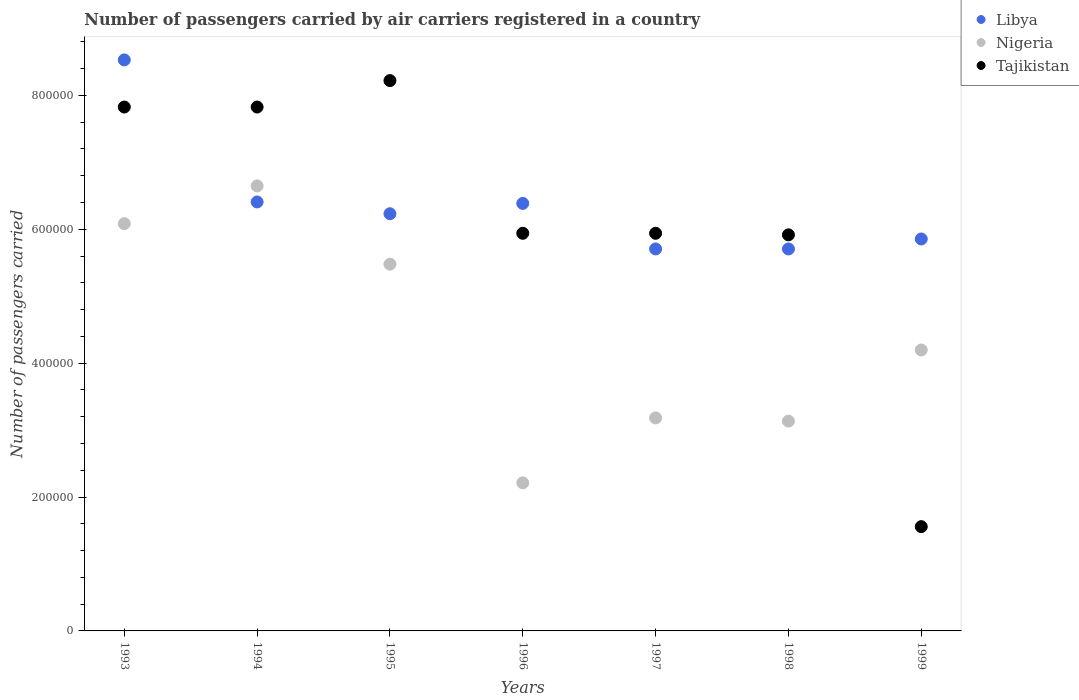How many different coloured dotlines are there?
Keep it short and to the point. 3. Is the number of dotlines equal to the number of legend labels?
Provide a succinct answer. Yes. What is the number of passengers carried by air carriers in Libya in 1993?
Offer a very short reply. 8.53e+05. Across all years, what is the maximum number of passengers carried by air carriers in Nigeria?
Give a very brief answer. 6.65e+05. Across all years, what is the minimum number of passengers carried by air carriers in Nigeria?
Provide a succinct answer. 2.21e+05. In which year was the number of passengers carried by air carriers in Tajikistan minimum?
Your answer should be very brief. 1999. What is the total number of passengers carried by air carriers in Tajikistan in the graph?
Your answer should be very brief. 4.32e+06. What is the difference between the number of passengers carried by air carriers in Nigeria in 1994 and that in 1999?
Offer a terse response. 2.45e+05. What is the difference between the number of passengers carried by air carriers in Tajikistan in 1993 and the number of passengers carried by air carriers in Nigeria in 1999?
Offer a very short reply. 3.63e+05. What is the average number of passengers carried by air carriers in Nigeria per year?
Give a very brief answer. 4.42e+05. In the year 1998, what is the difference between the number of passengers carried by air carriers in Libya and number of passengers carried by air carriers in Nigeria?
Provide a succinct answer. 2.57e+05. What is the ratio of the number of passengers carried by air carriers in Tajikistan in 1994 to that in 1997?
Provide a succinct answer. 1.32. Is the number of passengers carried by air carriers in Libya in 1994 less than that in 1996?
Ensure brevity in your answer.  No. Is the difference between the number of passengers carried by air carriers in Libya in 1997 and 1998 greater than the difference between the number of passengers carried by air carriers in Nigeria in 1997 and 1998?
Your answer should be very brief. No. What is the difference between the highest and the second highest number of passengers carried by air carriers in Nigeria?
Keep it short and to the point. 5.64e+04. What is the difference between the highest and the lowest number of passengers carried by air carriers in Nigeria?
Your answer should be very brief. 4.44e+05. Is the sum of the number of passengers carried by air carriers in Nigeria in 1997 and 1999 greater than the maximum number of passengers carried by air carriers in Tajikistan across all years?
Offer a very short reply. No. Is it the case that in every year, the sum of the number of passengers carried by air carriers in Libya and number of passengers carried by air carriers in Tajikistan  is greater than the number of passengers carried by air carriers in Nigeria?
Your answer should be very brief. Yes. Does the number of passengers carried by air carriers in Nigeria monotonically increase over the years?
Ensure brevity in your answer.  No. Is the number of passengers carried by air carriers in Libya strictly less than the number of passengers carried by air carriers in Nigeria over the years?
Give a very brief answer. No. How many dotlines are there?
Provide a short and direct response. 3. Does the graph contain any zero values?
Offer a very short reply. No. Where does the legend appear in the graph?
Ensure brevity in your answer.  Top right. How many legend labels are there?
Offer a terse response. 3. What is the title of the graph?
Provide a short and direct response. Number of passengers carried by air carriers registered in a country. What is the label or title of the Y-axis?
Offer a very short reply. Number of passengers carried. What is the Number of passengers carried in Libya in 1993?
Keep it short and to the point. 8.53e+05. What is the Number of passengers carried of Nigeria in 1993?
Keep it short and to the point. 6.08e+05. What is the Number of passengers carried in Tajikistan in 1993?
Your answer should be very brief. 7.83e+05. What is the Number of passengers carried in Libya in 1994?
Make the answer very short. 6.41e+05. What is the Number of passengers carried in Nigeria in 1994?
Offer a very short reply. 6.65e+05. What is the Number of passengers carried in Tajikistan in 1994?
Provide a short and direct response. 7.83e+05. What is the Number of passengers carried in Libya in 1995?
Offer a terse response. 6.23e+05. What is the Number of passengers carried of Nigeria in 1995?
Your answer should be very brief. 5.48e+05. What is the Number of passengers carried in Tajikistan in 1995?
Your answer should be compact. 8.22e+05. What is the Number of passengers carried of Libya in 1996?
Make the answer very short. 6.39e+05. What is the Number of passengers carried of Nigeria in 1996?
Keep it short and to the point. 2.21e+05. What is the Number of passengers carried of Tajikistan in 1996?
Your answer should be very brief. 5.94e+05. What is the Number of passengers carried of Libya in 1997?
Your answer should be compact. 5.71e+05. What is the Number of passengers carried of Nigeria in 1997?
Your response must be concise. 3.18e+05. What is the Number of passengers carried in Tajikistan in 1997?
Provide a succinct answer. 5.94e+05. What is the Number of passengers carried in Libya in 1998?
Make the answer very short. 5.71e+05. What is the Number of passengers carried in Nigeria in 1998?
Give a very brief answer. 3.13e+05. What is the Number of passengers carried of Tajikistan in 1998?
Offer a very short reply. 5.92e+05. What is the Number of passengers carried of Libya in 1999?
Offer a very short reply. 5.86e+05. What is the Number of passengers carried of Nigeria in 1999?
Your response must be concise. 4.20e+05. What is the Number of passengers carried in Tajikistan in 1999?
Provide a succinct answer. 1.56e+05. Across all years, what is the maximum Number of passengers carried of Libya?
Provide a short and direct response. 8.53e+05. Across all years, what is the maximum Number of passengers carried of Nigeria?
Offer a very short reply. 6.65e+05. Across all years, what is the maximum Number of passengers carried in Tajikistan?
Your answer should be compact. 8.22e+05. Across all years, what is the minimum Number of passengers carried in Libya?
Your answer should be very brief. 5.71e+05. Across all years, what is the minimum Number of passengers carried in Nigeria?
Your answer should be very brief. 2.21e+05. Across all years, what is the minimum Number of passengers carried in Tajikistan?
Ensure brevity in your answer.  1.56e+05. What is the total Number of passengers carried of Libya in the graph?
Your answer should be compact. 4.48e+06. What is the total Number of passengers carried of Nigeria in the graph?
Your answer should be compact. 3.09e+06. What is the total Number of passengers carried in Tajikistan in the graph?
Make the answer very short. 4.32e+06. What is the difference between the Number of passengers carried of Libya in 1993 and that in 1994?
Keep it short and to the point. 2.12e+05. What is the difference between the Number of passengers carried of Nigeria in 1993 and that in 1994?
Give a very brief answer. -5.64e+04. What is the difference between the Number of passengers carried of Libya in 1993 and that in 1995?
Make the answer very short. 2.30e+05. What is the difference between the Number of passengers carried of Nigeria in 1993 and that in 1995?
Provide a succinct answer. 6.05e+04. What is the difference between the Number of passengers carried in Tajikistan in 1993 and that in 1995?
Your answer should be very brief. -3.95e+04. What is the difference between the Number of passengers carried in Libya in 1993 and that in 1996?
Provide a succinct answer. 2.14e+05. What is the difference between the Number of passengers carried in Nigeria in 1993 and that in 1996?
Offer a very short reply. 3.87e+05. What is the difference between the Number of passengers carried of Tajikistan in 1993 and that in 1996?
Provide a short and direct response. 1.89e+05. What is the difference between the Number of passengers carried of Libya in 1993 and that in 1997?
Offer a very short reply. 2.82e+05. What is the difference between the Number of passengers carried of Nigeria in 1993 and that in 1997?
Make the answer very short. 2.90e+05. What is the difference between the Number of passengers carried in Tajikistan in 1993 and that in 1997?
Make the answer very short. 1.89e+05. What is the difference between the Number of passengers carried of Libya in 1993 and that in 1998?
Ensure brevity in your answer.  2.82e+05. What is the difference between the Number of passengers carried of Nigeria in 1993 and that in 1998?
Provide a succinct answer. 2.95e+05. What is the difference between the Number of passengers carried of Tajikistan in 1993 and that in 1998?
Make the answer very short. 1.91e+05. What is the difference between the Number of passengers carried in Libya in 1993 and that in 1999?
Make the answer very short. 2.68e+05. What is the difference between the Number of passengers carried in Nigeria in 1993 and that in 1999?
Give a very brief answer. 1.89e+05. What is the difference between the Number of passengers carried of Tajikistan in 1993 and that in 1999?
Give a very brief answer. 6.27e+05. What is the difference between the Number of passengers carried of Libya in 1994 and that in 1995?
Provide a short and direct response. 1.76e+04. What is the difference between the Number of passengers carried in Nigeria in 1994 and that in 1995?
Your response must be concise. 1.17e+05. What is the difference between the Number of passengers carried of Tajikistan in 1994 and that in 1995?
Provide a short and direct response. -3.95e+04. What is the difference between the Number of passengers carried in Libya in 1994 and that in 1996?
Offer a terse response. 2200. What is the difference between the Number of passengers carried of Nigeria in 1994 and that in 1996?
Offer a terse response. 4.44e+05. What is the difference between the Number of passengers carried of Tajikistan in 1994 and that in 1996?
Offer a very short reply. 1.89e+05. What is the difference between the Number of passengers carried in Libya in 1994 and that in 1997?
Keep it short and to the point. 7.02e+04. What is the difference between the Number of passengers carried in Nigeria in 1994 and that in 1997?
Offer a very short reply. 3.47e+05. What is the difference between the Number of passengers carried in Tajikistan in 1994 and that in 1997?
Provide a succinct answer. 1.89e+05. What is the difference between the Number of passengers carried of Libya in 1994 and that in 1998?
Provide a short and direct response. 7.02e+04. What is the difference between the Number of passengers carried in Nigeria in 1994 and that in 1998?
Offer a terse response. 3.51e+05. What is the difference between the Number of passengers carried of Tajikistan in 1994 and that in 1998?
Make the answer very short. 1.91e+05. What is the difference between the Number of passengers carried of Libya in 1994 and that in 1999?
Offer a very short reply. 5.53e+04. What is the difference between the Number of passengers carried of Nigeria in 1994 and that in 1999?
Your answer should be very brief. 2.45e+05. What is the difference between the Number of passengers carried of Tajikistan in 1994 and that in 1999?
Offer a very short reply. 6.27e+05. What is the difference between the Number of passengers carried in Libya in 1995 and that in 1996?
Keep it short and to the point. -1.54e+04. What is the difference between the Number of passengers carried in Nigeria in 1995 and that in 1996?
Your answer should be compact. 3.27e+05. What is the difference between the Number of passengers carried in Tajikistan in 1995 and that in 1996?
Your answer should be compact. 2.28e+05. What is the difference between the Number of passengers carried of Libya in 1995 and that in 1997?
Offer a very short reply. 5.26e+04. What is the difference between the Number of passengers carried of Nigeria in 1995 and that in 1997?
Your answer should be very brief. 2.30e+05. What is the difference between the Number of passengers carried of Tajikistan in 1995 and that in 1997?
Your answer should be compact. 2.28e+05. What is the difference between the Number of passengers carried in Libya in 1995 and that in 1998?
Offer a very short reply. 5.26e+04. What is the difference between the Number of passengers carried in Nigeria in 1995 and that in 1998?
Make the answer very short. 2.34e+05. What is the difference between the Number of passengers carried of Tajikistan in 1995 and that in 1998?
Offer a very short reply. 2.30e+05. What is the difference between the Number of passengers carried in Libya in 1995 and that in 1999?
Your response must be concise. 3.77e+04. What is the difference between the Number of passengers carried of Nigeria in 1995 and that in 1999?
Offer a terse response. 1.28e+05. What is the difference between the Number of passengers carried in Tajikistan in 1995 and that in 1999?
Provide a succinct answer. 6.66e+05. What is the difference between the Number of passengers carried of Libya in 1996 and that in 1997?
Your response must be concise. 6.80e+04. What is the difference between the Number of passengers carried in Nigeria in 1996 and that in 1997?
Make the answer very short. -9.70e+04. What is the difference between the Number of passengers carried in Tajikistan in 1996 and that in 1997?
Offer a very short reply. 0. What is the difference between the Number of passengers carried in Libya in 1996 and that in 1998?
Your answer should be compact. 6.80e+04. What is the difference between the Number of passengers carried of Nigeria in 1996 and that in 1998?
Your answer should be very brief. -9.22e+04. What is the difference between the Number of passengers carried of Tajikistan in 1996 and that in 1998?
Your response must be concise. 2300. What is the difference between the Number of passengers carried in Libya in 1996 and that in 1999?
Provide a succinct answer. 5.31e+04. What is the difference between the Number of passengers carried of Nigeria in 1996 and that in 1999?
Offer a terse response. -1.98e+05. What is the difference between the Number of passengers carried of Tajikistan in 1996 and that in 1999?
Keep it short and to the point. 4.38e+05. What is the difference between the Number of passengers carried in Nigeria in 1997 and that in 1998?
Give a very brief answer. 4800. What is the difference between the Number of passengers carried of Tajikistan in 1997 and that in 1998?
Offer a terse response. 2300. What is the difference between the Number of passengers carried of Libya in 1997 and that in 1999?
Make the answer very short. -1.49e+04. What is the difference between the Number of passengers carried of Nigeria in 1997 and that in 1999?
Offer a terse response. -1.02e+05. What is the difference between the Number of passengers carried of Tajikistan in 1997 and that in 1999?
Keep it short and to the point. 4.38e+05. What is the difference between the Number of passengers carried of Libya in 1998 and that in 1999?
Ensure brevity in your answer.  -1.49e+04. What is the difference between the Number of passengers carried in Nigeria in 1998 and that in 1999?
Give a very brief answer. -1.06e+05. What is the difference between the Number of passengers carried of Tajikistan in 1998 and that in 1999?
Keep it short and to the point. 4.36e+05. What is the difference between the Number of passengers carried of Libya in 1993 and the Number of passengers carried of Nigeria in 1994?
Your response must be concise. 1.88e+05. What is the difference between the Number of passengers carried of Libya in 1993 and the Number of passengers carried of Tajikistan in 1994?
Your answer should be very brief. 7.04e+04. What is the difference between the Number of passengers carried in Nigeria in 1993 and the Number of passengers carried in Tajikistan in 1994?
Your answer should be compact. -1.74e+05. What is the difference between the Number of passengers carried in Libya in 1993 and the Number of passengers carried in Nigeria in 1995?
Offer a very short reply. 3.05e+05. What is the difference between the Number of passengers carried of Libya in 1993 and the Number of passengers carried of Tajikistan in 1995?
Provide a short and direct response. 3.09e+04. What is the difference between the Number of passengers carried of Nigeria in 1993 and the Number of passengers carried of Tajikistan in 1995?
Provide a succinct answer. -2.14e+05. What is the difference between the Number of passengers carried of Libya in 1993 and the Number of passengers carried of Nigeria in 1996?
Your answer should be very brief. 6.32e+05. What is the difference between the Number of passengers carried of Libya in 1993 and the Number of passengers carried of Tajikistan in 1996?
Your response must be concise. 2.59e+05. What is the difference between the Number of passengers carried in Nigeria in 1993 and the Number of passengers carried in Tajikistan in 1996?
Ensure brevity in your answer.  1.44e+04. What is the difference between the Number of passengers carried of Libya in 1993 and the Number of passengers carried of Nigeria in 1997?
Offer a terse response. 5.35e+05. What is the difference between the Number of passengers carried of Libya in 1993 and the Number of passengers carried of Tajikistan in 1997?
Give a very brief answer. 2.59e+05. What is the difference between the Number of passengers carried of Nigeria in 1993 and the Number of passengers carried of Tajikistan in 1997?
Offer a terse response. 1.44e+04. What is the difference between the Number of passengers carried of Libya in 1993 and the Number of passengers carried of Nigeria in 1998?
Give a very brief answer. 5.40e+05. What is the difference between the Number of passengers carried in Libya in 1993 and the Number of passengers carried in Tajikistan in 1998?
Offer a terse response. 2.61e+05. What is the difference between the Number of passengers carried of Nigeria in 1993 and the Number of passengers carried of Tajikistan in 1998?
Keep it short and to the point. 1.67e+04. What is the difference between the Number of passengers carried of Libya in 1993 and the Number of passengers carried of Nigeria in 1999?
Your response must be concise. 4.33e+05. What is the difference between the Number of passengers carried in Libya in 1993 and the Number of passengers carried in Tajikistan in 1999?
Offer a terse response. 6.97e+05. What is the difference between the Number of passengers carried of Nigeria in 1993 and the Number of passengers carried of Tajikistan in 1999?
Make the answer very short. 4.53e+05. What is the difference between the Number of passengers carried of Libya in 1994 and the Number of passengers carried of Nigeria in 1995?
Give a very brief answer. 9.29e+04. What is the difference between the Number of passengers carried in Libya in 1994 and the Number of passengers carried in Tajikistan in 1995?
Give a very brief answer. -1.81e+05. What is the difference between the Number of passengers carried of Nigeria in 1994 and the Number of passengers carried of Tajikistan in 1995?
Provide a succinct answer. -1.57e+05. What is the difference between the Number of passengers carried of Libya in 1994 and the Number of passengers carried of Nigeria in 1996?
Your response must be concise. 4.20e+05. What is the difference between the Number of passengers carried of Libya in 1994 and the Number of passengers carried of Tajikistan in 1996?
Give a very brief answer. 4.68e+04. What is the difference between the Number of passengers carried in Nigeria in 1994 and the Number of passengers carried in Tajikistan in 1996?
Your response must be concise. 7.08e+04. What is the difference between the Number of passengers carried in Libya in 1994 and the Number of passengers carried in Nigeria in 1997?
Provide a succinct answer. 3.23e+05. What is the difference between the Number of passengers carried of Libya in 1994 and the Number of passengers carried of Tajikistan in 1997?
Give a very brief answer. 4.68e+04. What is the difference between the Number of passengers carried in Nigeria in 1994 and the Number of passengers carried in Tajikistan in 1997?
Offer a very short reply. 7.08e+04. What is the difference between the Number of passengers carried of Libya in 1994 and the Number of passengers carried of Nigeria in 1998?
Your response must be concise. 3.27e+05. What is the difference between the Number of passengers carried of Libya in 1994 and the Number of passengers carried of Tajikistan in 1998?
Give a very brief answer. 4.91e+04. What is the difference between the Number of passengers carried of Nigeria in 1994 and the Number of passengers carried of Tajikistan in 1998?
Your response must be concise. 7.31e+04. What is the difference between the Number of passengers carried in Libya in 1994 and the Number of passengers carried in Nigeria in 1999?
Provide a short and direct response. 2.21e+05. What is the difference between the Number of passengers carried in Libya in 1994 and the Number of passengers carried in Tajikistan in 1999?
Keep it short and to the point. 4.85e+05. What is the difference between the Number of passengers carried in Nigeria in 1994 and the Number of passengers carried in Tajikistan in 1999?
Your answer should be very brief. 5.09e+05. What is the difference between the Number of passengers carried in Libya in 1995 and the Number of passengers carried in Nigeria in 1996?
Offer a very short reply. 4.02e+05. What is the difference between the Number of passengers carried in Libya in 1995 and the Number of passengers carried in Tajikistan in 1996?
Make the answer very short. 2.92e+04. What is the difference between the Number of passengers carried in Nigeria in 1995 and the Number of passengers carried in Tajikistan in 1996?
Make the answer very short. -4.61e+04. What is the difference between the Number of passengers carried in Libya in 1995 and the Number of passengers carried in Nigeria in 1997?
Offer a terse response. 3.05e+05. What is the difference between the Number of passengers carried of Libya in 1995 and the Number of passengers carried of Tajikistan in 1997?
Offer a very short reply. 2.92e+04. What is the difference between the Number of passengers carried in Nigeria in 1995 and the Number of passengers carried in Tajikistan in 1997?
Ensure brevity in your answer.  -4.61e+04. What is the difference between the Number of passengers carried in Libya in 1995 and the Number of passengers carried in Nigeria in 1998?
Your answer should be compact. 3.10e+05. What is the difference between the Number of passengers carried in Libya in 1995 and the Number of passengers carried in Tajikistan in 1998?
Make the answer very short. 3.15e+04. What is the difference between the Number of passengers carried in Nigeria in 1995 and the Number of passengers carried in Tajikistan in 1998?
Ensure brevity in your answer.  -4.38e+04. What is the difference between the Number of passengers carried in Libya in 1995 and the Number of passengers carried in Nigeria in 1999?
Provide a succinct answer. 2.04e+05. What is the difference between the Number of passengers carried in Libya in 1995 and the Number of passengers carried in Tajikistan in 1999?
Your answer should be compact. 4.67e+05. What is the difference between the Number of passengers carried of Nigeria in 1995 and the Number of passengers carried of Tajikistan in 1999?
Your response must be concise. 3.92e+05. What is the difference between the Number of passengers carried of Libya in 1996 and the Number of passengers carried of Nigeria in 1997?
Make the answer very short. 3.20e+05. What is the difference between the Number of passengers carried in Libya in 1996 and the Number of passengers carried in Tajikistan in 1997?
Offer a terse response. 4.46e+04. What is the difference between the Number of passengers carried of Nigeria in 1996 and the Number of passengers carried of Tajikistan in 1997?
Your response must be concise. -3.73e+05. What is the difference between the Number of passengers carried of Libya in 1996 and the Number of passengers carried of Nigeria in 1998?
Your answer should be compact. 3.25e+05. What is the difference between the Number of passengers carried of Libya in 1996 and the Number of passengers carried of Tajikistan in 1998?
Your answer should be compact. 4.69e+04. What is the difference between the Number of passengers carried of Nigeria in 1996 and the Number of passengers carried of Tajikistan in 1998?
Your answer should be compact. -3.70e+05. What is the difference between the Number of passengers carried of Libya in 1996 and the Number of passengers carried of Nigeria in 1999?
Offer a very short reply. 2.19e+05. What is the difference between the Number of passengers carried of Libya in 1996 and the Number of passengers carried of Tajikistan in 1999?
Give a very brief answer. 4.83e+05. What is the difference between the Number of passengers carried in Nigeria in 1996 and the Number of passengers carried in Tajikistan in 1999?
Provide a succinct answer. 6.54e+04. What is the difference between the Number of passengers carried in Libya in 1997 and the Number of passengers carried in Nigeria in 1998?
Offer a terse response. 2.57e+05. What is the difference between the Number of passengers carried in Libya in 1997 and the Number of passengers carried in Tajikistan in 1998?
Offer a very short reply. -2.11e+04. What is the difference between the Number of passengers carried in Nigeria in 1997 and the Number of passengers carried in Tajikistan in 1998?
Your response must be concise. -2.74e+05. What is the difference between the Number of passengers carried in Libya in 1997 and the Number of passengers carried in Nigeria in 1999?
Make the answer very short. 1.51e+05. What is the difference between the Number of passengers carried in Libya in 1997 and the Number of passengers carried in Tajikistan in 1999?
Offer a terse response. 4.15e+05. What is the difference between the Number of passengers carried in Nigeria in 1997 and the Number of passengers carried in Tajikistan in 1999?
Provide a succinct answer. 1.62e+05. What is the difference between the Number of passengers carried of Libya in 1998 and the Number of passengers carried of Nigeria in 1999?
Make the answer very short. 1.51e+05. What is the difference between the Number of passengers carried of Libya in 1998 and the Number of passengers carried of Tajikistan in 1999?
Provide a succinct answer. 4.15e+05. What is the difference between the Number of passengers carried in Nigeria in 1998 and the Number of passengers carried in Tajikistan in 1999?
Your response must be concise. 1.58e+05. What is the average Number of passengers carried in Libya per year?
Ensure brevity in your answer.  6.40e+05. What is the average Number of passengers carried of Nigeria per year?
Offer a very short reply. 4.42e+05. What is the average Number of passengers carried of Tajikistan per year?
Provide a short and direct response. 6.18e+05. In the year 1993, what is the difference between the Number of passengers carried of Libya and Number of passengers carried of Nigeria?
Offer a terse response. 2.45e+05. In the year 1993, what is the difference between the Number of passengers carried in Libya and Number of passengers carried in Tajikistan?
Provide a short and direct response. 7.04e+04. In the year 1993, what is the difference between the Number of passengers carried of Nigeria and Number of passengers carried of Tajikistan?
Give a very brief answer. -1.74e+05. In the year 1994, what is the difference between the Number of passengers carried of Libya and Number of passengers carried of Nigeria?
Ensure brevity in your answer.  -2.40e+04. In the year 1994, what is the difference between the Number of passengers carried of Libya and Number of passengers carried of Tajikistan?
Your answer should be compact. -1.42e+05. In the year 1994, what is the difference between the Number of passengers carried in Nigeria and Number of passengers carried in Tajikistan?
Your answer should be compact. -1.18e+05. In the year 1995, what is the difference between the Number of passengers carried of Libya and Number of passengers carried of Nigeria?
Your answer should be very brief. 7.53e+04. In the year 1995, what is the difference between the Number of passengers carried in Libya and Number of passengers carried in Tajikistan?
Keep it short and to the point. -1.99e+05. In the year 1995, what is the difference between the Number of passengers carried in Nigeria and Number of passengers carried in Tajikistan?
Provide a short and direct response. -2.74e+05. In the year 1996, what is the difference between the Number of passengers carried in Libya and Number of passengers carried in Nigeria?
Give a very brief answer. 4.17e+05. In the year 1996, what is the difference between the Number of passengers carried of Libya and Number of passengers carried of Tajikistan?
Your answer should be compact. 4.46e+04. In the year 1996, what is the difference between the Number of passengers carried of Nigeria and Number of passengers carried of Tajikistan?
Your answer should be very brief. -3.73e+05. In the year 1997, what is the difference between the Number of passengers carried of Libya and Number of passengers carried of Nigeria?
Your answer should be very brief. 2.52e+05. In the year 1997, what is the difference between the Number of passengers carried of Libya and Number of passengers carried of Tajikistan?
Provide a succinct answer. -2.34e+04. In the year 1997, what is the difference between the Number of passengers carried in Nigeria and Number of passengers carried in Tajikistan?
Your answer should be very brief. -2.76e+05. In the year 1998, what is the difference between the Number of passengers carried in Libya and Number of passengers carried in Nigeria?
Your answer should be very brief. 2.57e+05. In the year 1998, what is the difference between the Number of passengers carried of Libya and Number of passengers carried of Tajikistan?
Offer a terse response. -2.11e+04. In the year 1998, what is the difference between the Number of passengers carried in Nigeria and Number of passengers carried in Tajikistan?
Provide a succinct answer. -2.78e+05. In the year 1999, what is the difference between the Number of passengers carried of Libya and Number of passengers carried of Nigeria?
Offer a very short reply. 1.66e+05. In the year 1999, what is the difference between the Number of passengers carried of Libya and Number of passengers carried of Tajikistan?
Provide a short and direct response. 4.30e+05. In the year 1999, what is the difference between the Number of passengers carried in Nigeria and Number of passengers carried in Tajikistan?
Offer a terse response. 2.64e+05. What is the ratio of the Number of passengers carried in Libya in 1993 to that in 1994?
Make the answer very short. 1.33. What is the ratio of the Number of passengers carried in Nigeria in 1993 to that in 1994?
Provide a short and direct response. 0.92. What is the ratio of the Number of passengers carried in Tajikistan in 1993 to that in 1994?
Give a very brief answer. 1. What is the ratio of the Number of passengers carried in Libya in 1993 to that in 1995?
Provide a succinct answer. 1.37. What is the ratio of the Number of passengers carried in Nigeria in 1993 to that in 1995?
Make the answer very short. 1.11. What is the ratio of the Number of passengers carried in Libya in 1993 to that in 1996?
Your answer should be very brief. 1.34. What is the ratio of the Number of passengers carried of Nigeria in 1993 to that in 1996?
Make the answer very short. 2.75. What is the ratio of the Number of passengers carried of Tajikistan in 1993 to that in 1996?
Offer a terse response. 1.32. What is the ratio of the Number of passengers carried in Libya in 1993 to that in 1997?
Keep it short and to the point. 1.49. What is the ratio of the Number of passengers carried of Nigeria in 1993 to that in 1997?
Keep it short and to the point. 1.91. What is the ratio of the Number of passengers carried in Tajikistan in 1993 to that in 1997?
Offer a terse response. 1.32. What is the ratio of the Number of passengers carried of Libya in 1993 to that in 1998?
Make the answer very short. 1.49. What is the ratio of the Number of passengers carried in Nigeria in 1993 to that in 1998?
Give a very brief answer. 1.94. What is the ratio of the Number of passengers carried in Tajikistan in 1993 to that in 1998?
Keep it short and to the point. 1.32. What is the ratio of the Number of passengers carried of Libya in 1993 to that in 1999?
Your answer should be very brief. 1.46. What is the ratio of the Number of passengers carried of Nigeria in 1993 to that in 1999?
Your answer should be very brief. 1.45. What is the ratio of the Number of passengers carried of Tajikistan in 1993 to that in 1999?
Provide a short and direct response. 5.02. What is the ratio of the Number of passengers carried in Libya in 1994 to that in 1995?
Provide a succinct answer. 1.03. What is the ratio of the Number of passengers carried of Nigeria in 1994 to that in 1995?
Offer a terse response. 1.21. What is the ratio of the Number of passengers carried of Tajikistan in 1994 to that in 1995?
Ensure brevity in your answer.  0.95. What is the ratio of the Number of passengers carried in Nigeria in 1994 to that in 1996?
Make the answer very short. 3.01. What is the ratio of the Number of passengers carried in Tajikistan in 1994 to that in 1996?
Ensure brevity in your answer.  1.32. What is the ratio of the Number of passengers carried in Libya in 1994 to that in 1997?
Ensure brevity in your answer.  1.12. What is the ratio of the Number of passengers carried of Nigeria in 1994 to that in 1997?
Ensure brevity in your answer.  2.09. What is the ratio of the Number of passengers carried in Tajikistan in 1994 to that in 1997?
Provide a succinct answer. 1.32. What is the ratio of the Number of passengers carried of Libya in 1994 to that in 1998?
Your answer should be compact. 1.12. What is the ratio of the Number of passengers carried in Nigeria in 1994 to that in 1998?
Your response must be concise. 2.12. What is the ratio of the Number of passengers carried of Tajikistan in 1994 to that in 1998?
Offer a terse response. 1.32. What is the ratio of the Number of passengers carried in Libya in 1994 to that in 1999?
Your answer should be very brief. 1.09. What is the ratio of the Number of passengers carried of Nigeria in 1994 to that in 1999?
Give a very brief answer. 1.58. What is the ratio of the Number of passengers carried in Tajikistan in 1994 to that in 1999?
Make the answer very short. 5.02. What is the ratio of the Number of passengers carried in Libya in 1995 to that in 1996?
Your answer should be compact. 0.98. What is the ratio of the Number of passengers carried of Nigeria in 1995 to that in 1996?
Offer a terse response. 2.48. What is the ratio of the Number of passengers carried in Tajikistan in 1995 to that in 1996?
Your answer should be very brief. 1.38. What is the ratio of the Number of passengers carried in Libya in 1995 to that in 1997?
Make the answer very short. 1.09. What is the ratio of the Number of passengers carried of Nigeria in 1995 to that in 1997?
Give a very brief answer. 1.72. What is the ratio of the Number of passengers carried in Tajikistan in 1995 to that in 1997?
Provide a short and direct response. 1.38. What is the ratio of the Number of passengers carried of Libya in 1995 to that in 1998?
Your answer should be very brief. 1.09. What is the ratio of the Number of passengers carried in Nigeria in 1995 to that in 1998?
Offer a terse response. 1.75. What is the ratio of the Number of passengers carried in Tajikistan in 1995 to that in 1998?
Offer a very short reply. 1.39. What is the ratio of the Number of passengers carried in Libya in 1995 to that in 1999?
Make the answer very short. 1.06. What is the ratio of the Number of passengers carried of Nigeria in 1995 to that in 1999?
Provide a succinct answer. 1.31. What is the ratio of the Number of passengers carried of Tajikistan in 1995 to that in 1999?
Your answer should be compact. 5.28. What is the ratio of the Number of passengers carried of Libya in 1996 to that in 1997?
Your response must be concise. 1.12. What is the ratio of the Number of passengers carried in Nigeria in 1996 to that in 1997?
Keep it short and to the point. 0.7. What is the ratio of the Number of passengers carried of Libya in 1996 to that in 1998?
Provide a short and direct response. 1.12. What is the ratio of the Number of passengers carried of Nigeria in 1996 to that in 1998?
Your answer should be compact. 0.71. What is the ratio of the Number of passengers carried of Tajikistan in 1996 to that in 1998?
Give a very brief answer. 1. What is the ratio of the Number of passengers carried in Libya in 1996 to that in 1999?
Offer a terse response. 1.09. What is the ratio of the Number of passengers carried of Nigeria in 1996 to that in 1999?
Offer a very short reply. 0.53. What is the ratio of the Number of passengers carried of Tajikistan in 1996 to that in 1999?
Provide a succinct answer. 3.81. What is the ratio of the Number of passengers carried of Libya in 1997 to that in 1998?
Offer a very short reply. 1. What is the ratio of the Number of passengers carried of Nigeria in 1997 to that in 1998?
Provide a succinct answer. 1.02. What is the ratio of the Number of passengers carried of Libya in 1997 to that in 1999?
Keep it short and to the point. 0.97. What is the ratio of the Number of passengers carried of Nigeria in 1997 to that in 1999?
Make the answer very short. 0.76. What is the ratio of the Number of passengers carried of Tajikistan in 1997 to that in 1999?
Offer a terse response. 3.81. What is the ratio of the Number of passengers carried of Libya in 1998 to that in 1999?
Provide a succinct answer. 0.97. What is the ratio of the Number of passengers carried in Nigeria in 1998 to that in 1999?
Offer a very short reply. 0.75. What is the ratio of the Number of passengers carried in Tajikistan in 1998 to that in 1999?
Offer a very short reply. 3.8. What is the difference between the highest and the second highest Number of passengers carried in Libya?
Provide a succinct answer. 2.12e+05. What is the difference between the highest and the second highest Number of passengers carried in Nigeria?
Provide a short and direct response. 5.64e+04. What is the difference between the highest and the second highest Number of passengers carried of Tajikistan?
Offer a terse response. 3.95e+04. What is the difference between the highest and the lowest Number of passengers carried of Libya?
Make the answer very short. 2.82e+05. What is the difference between the highest and the lowest Number of passengers carried of Nigeria?
Your response must be concise. 4.44e+05. What is the difference between the highest and the lowest Number of passengers carried in Tajikistan?
Your answer should be very brief. 6.66e+05. 